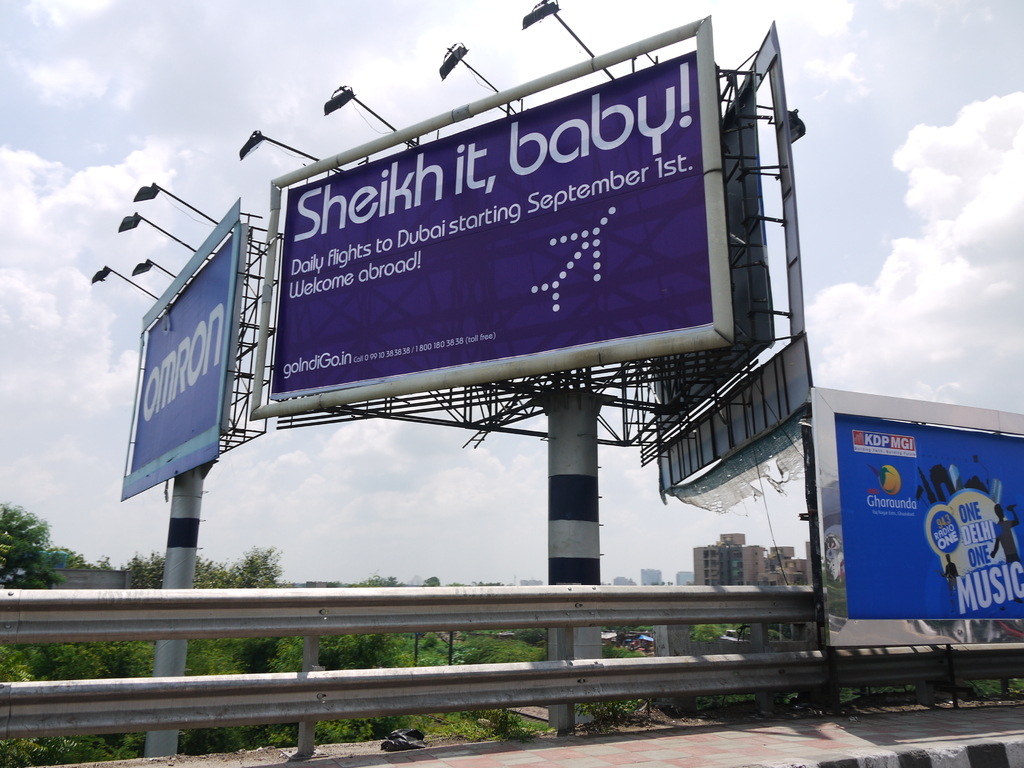Discuss the impact of outdoor advertising like this billboard on urban landscapes. Outdoor advertising such as this billboard has a significant impact on urban landscapes by adding visual elements that can attract attention and deliver messages effectively. However, they also contribute to visual clutter and can influence the aesthetic of the area, affecting how spaces feel and function. 